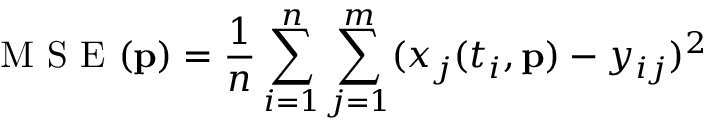Convert formula to latex. <formula><loc_0><loc_0><loc_500><loc_500>M S E ( p ) = \frac { 1 } { n } \sum _ { i = 1 } ^ { n } \sum _ { j = 1 } ^ { m } ( x _ { j } ( t _ { i } , p ) - y _ { i j } ) ^ { 2 }</formula> 